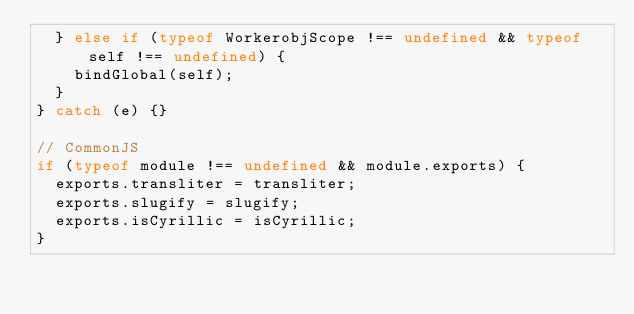<code> <loc_0><loc_0><loc_500><loc_500><_JavaScript_>  } else if (typeof WorkerobjScope !== undefined && typeof self !== undefined) {
    bindGlobal(self);
  }
} catch (e) {}

// CommonJS
if (typeof module !== undefined && module.exports) {
  exports.transliter = transliter;
  exports.slugify = slugify;
  exports.isCyrillic = isCyrillic;
}
</code> 